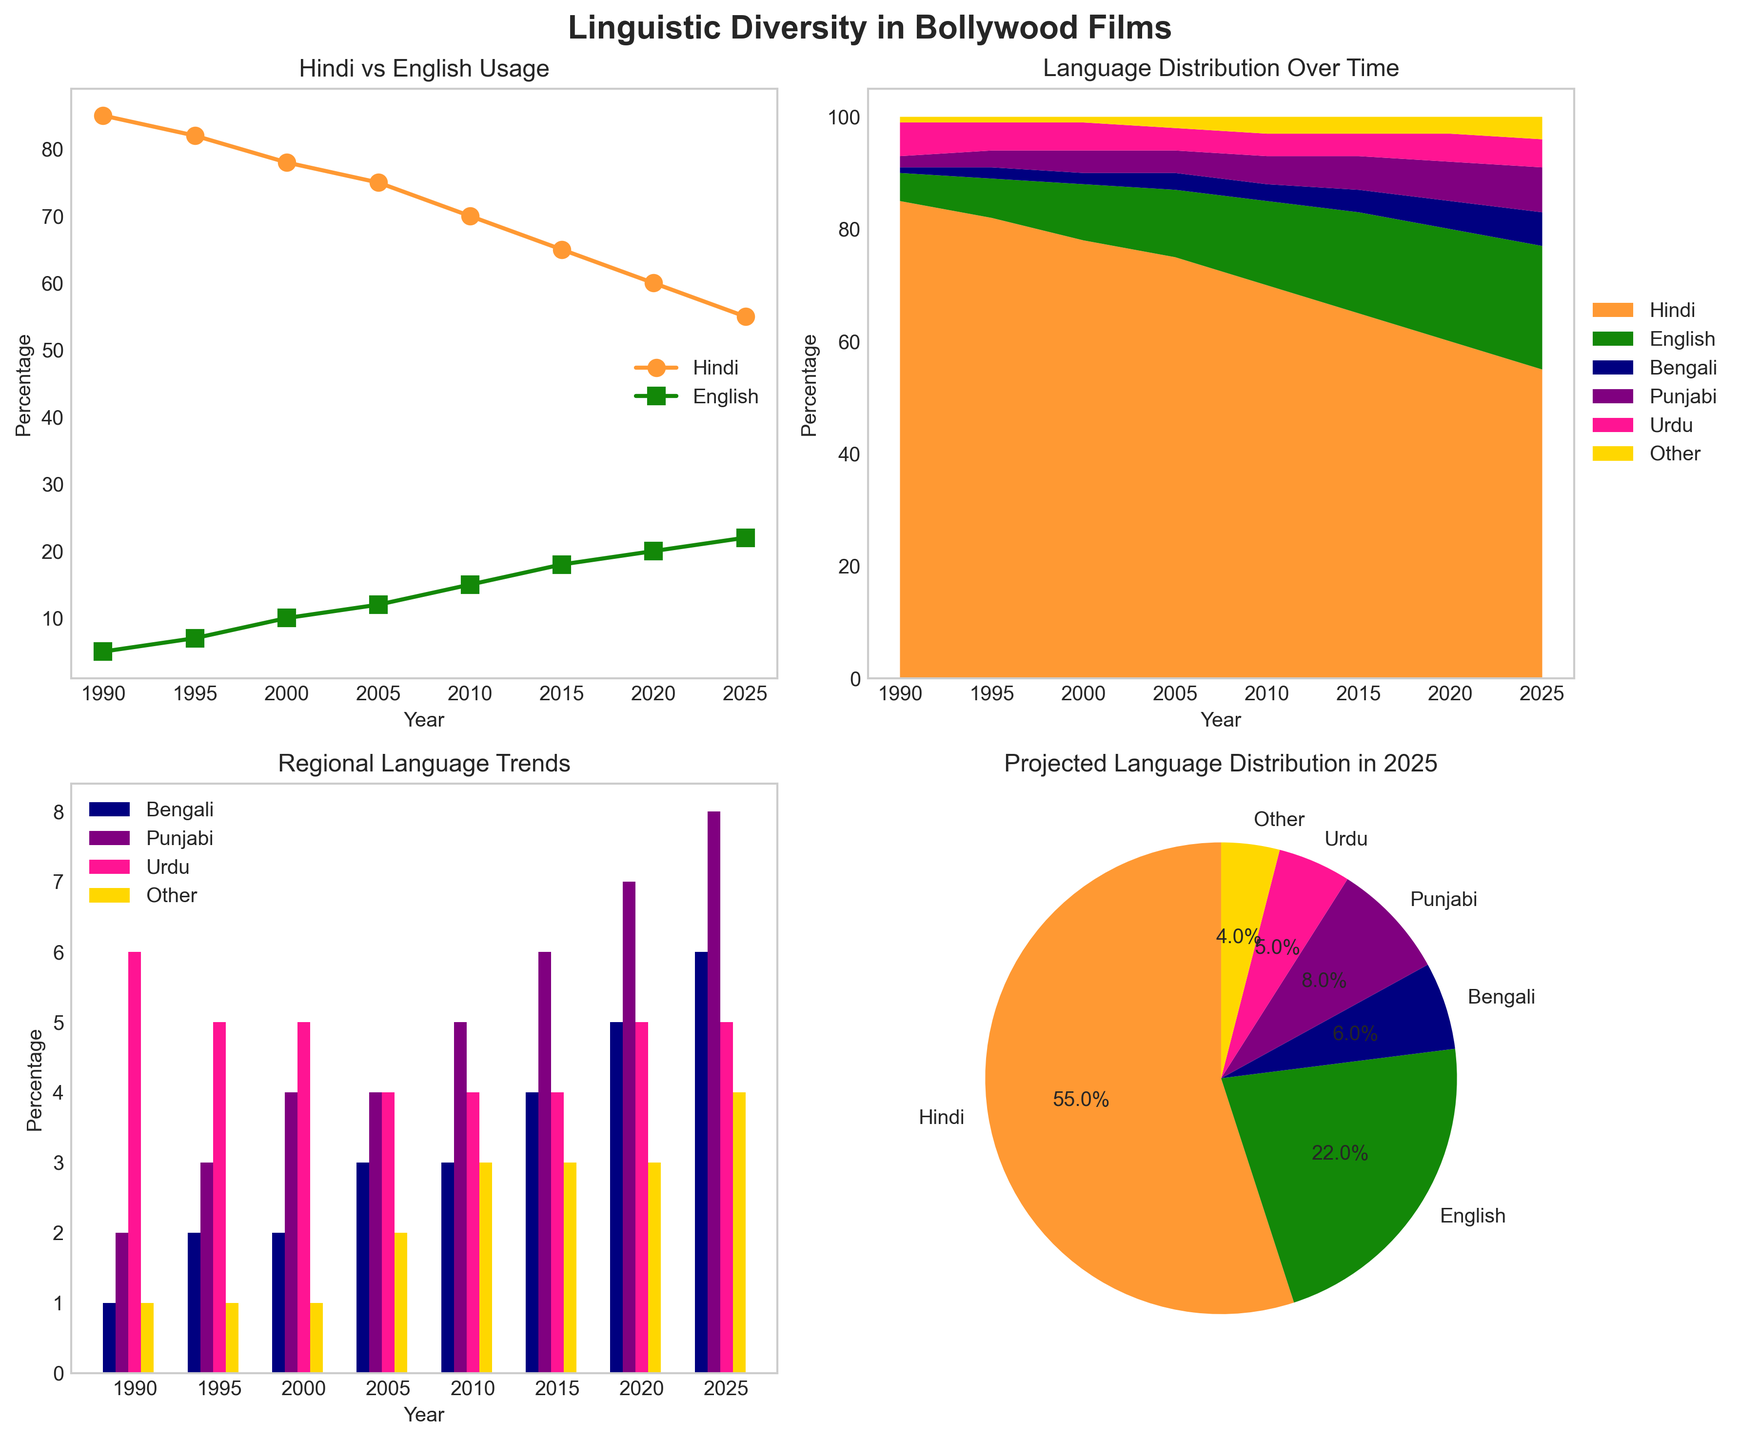What trend can you observe in the usage of Hindi and English over the years? By looking at the line plot titled 'Hindi vs English Usage', it's clear that the percentage of dialogues in Hindi has been decreasing, while the percentage of dialogues in English has been increasing from 1990 to 2025.
Answer: Hindi decreasing, English increasing Comparing Bengali and Punjabi, which language saw a greater increase in usage from 1990 to 2025? Examine the grouped bar plot titled 'Regional Language Trends'. For Bengali, the percentage increased from 1% in 1990 to 6% in 2025, an increase of 5%. For Punjabi, it increased from 2% in 1990 to 8% in 2025, an increase of 6%. Hence, Punjabi saw a greater increase.
Answer: Punjabi How has the distribution of Urdu compared to 'Other' languages in 2025 changed relative to 1990? According to the grouped bar plot, Urdu held 6% in 1990 and 'Other' languages held 1%. In 2025, Urdu is 5% and 'Other' languages are 4%. Urdu's percentage decreased by 1%, while 'Other' languages increased by 3%.
Answer: Urdu decreased, 'Other' increased Which language had the highest percentage of dialogue in 2025? The pie chart labeled 'Projected Language Distribution in 2025' shows the distribution. Hindi has the largest segment.
Answer: Hindi What is the combined percentage of dialogues in Hindi and English in 2000? Referring to the line plot for 2000, Hindi is at 78% and English is at 10%. Adding these two values, 78% + 10% = 88%.
Answer: 88% Excluding Hindi and English, what is the total percentage of dialogues attributed to other languages in 2020? From the stacked area plot for the year 2020, summing Bengali (5%), Punjabi (7%), Urdu (5%), and Other (3%) gives 5% + 7% + 5% + 3% = 20%.
Answer: 20% Which language had a steady increase in its percentage from 1990 to 2025? Reviewing the stacked area plot or the grouped bar plot, we can see that English showed a steady increase each year from 1990 (5%) to 2025 (22%).
Answer: English From the pie chart, what percentage of dialogues in 2025 are in Bengali? From the 'Projected Language Distribution in 2025' pie chart, Bengali holds 6% of dialogues.
Answer: 6% What is the main visual difference between the line plot and the stacked area plot for illustrating trends? The line plot focuses on two languages (Hindi and English) separately over time, showing their individual trends. The stacked area plot gives a comprehensive view of all languages combined over time, showing overall distribution changes.
Answer: Separate trends vs. combined distribution Comparing the years 2010 to 2020, which language saw an increase in both the percentage and absolute amount in dialogues? The grouped bar plot shows that for Bengali, the percentage increased from 3% in 2010 to 5% in 2020, an increase of 2%. In absolute terms, since the total percentage is 100%, the 2% increase reflects growth in both percentage and absolute terms.
Answer: Bengali 